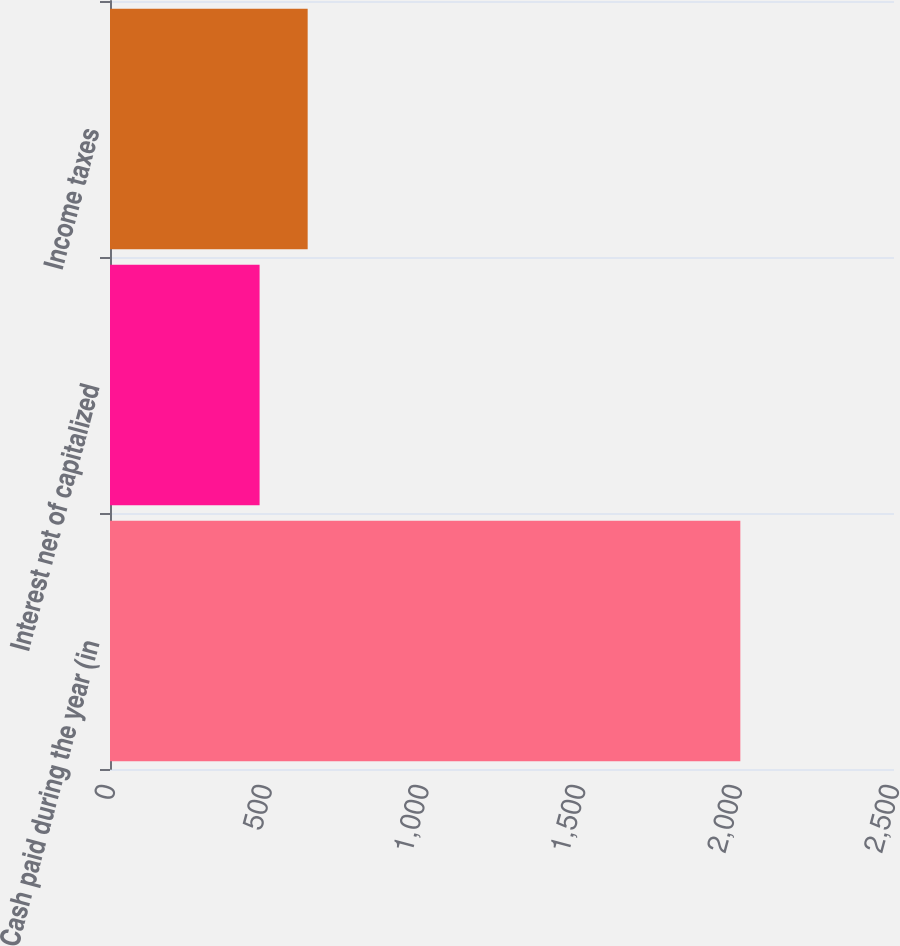Convert chart. <chart><loc_0><loc_0><loc_500><loc_500><bar_chart><fcel>Cash paid during the year (in<fcel>Interest net of capitalized<fcel>Income taxes<nl><fcel>2010<fcel>477<fcel>630.3<nl></chart> 